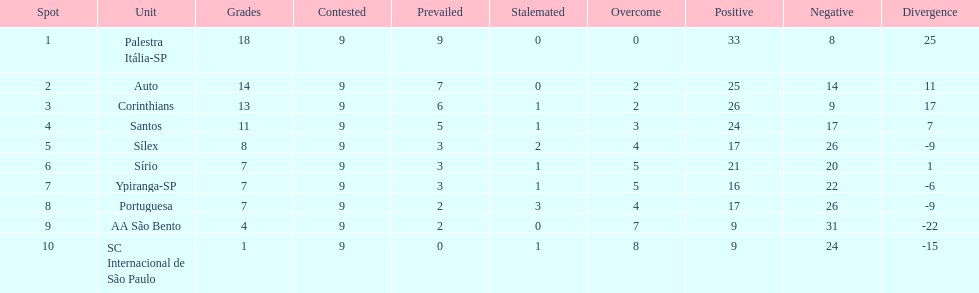How many points did the brazilian football team auto get in 1926? 14. 